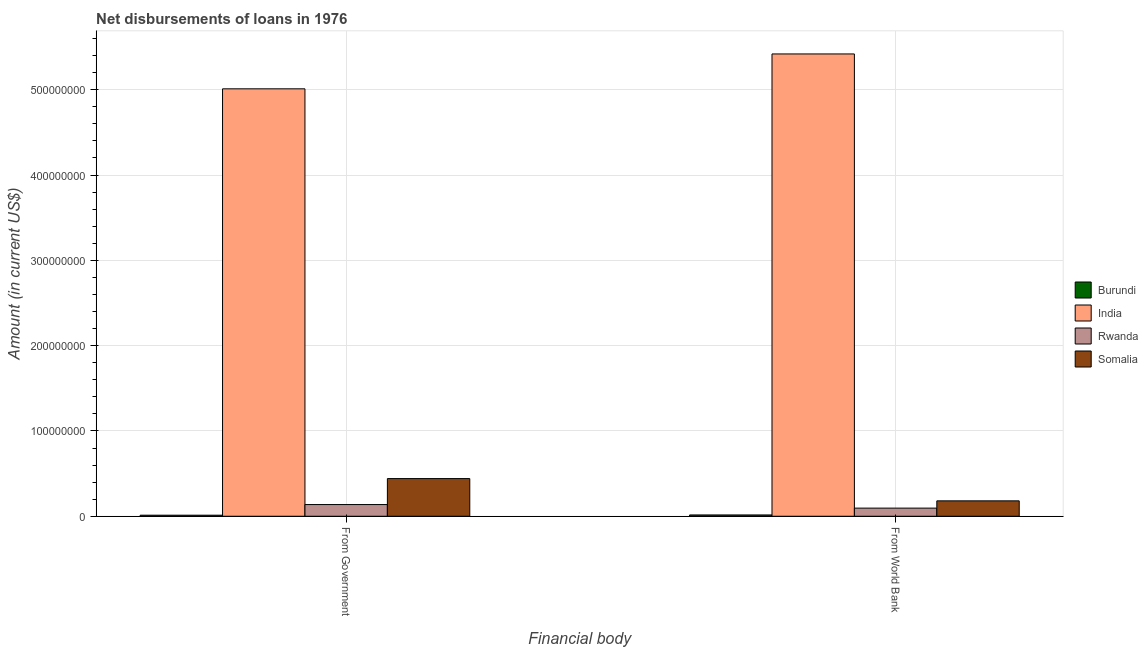Are the number of bars per tick equal to the number of legend labels?
Your answer should be compact. Yes. Are the number of bars on each tick of the X-axis equal?
Provide a succinct answer. Yes. How many bars are there on the 2nd tick from the right?
Offer a very short reply. 4. What is the label of the 2nd group of bars from the left?
Your response must be concise. From World Bank. What is the net disbursements of loan from government in India?
Keep it short and to the point. 5.01e+08. Across all countries, what is the maximum net disbursements of loan from government?
Provide a succinct answer. 5.01e+08. Across all countries, what is the minimum net disbursements of loan from world bank?
Your answer should be very brief. 1.54e+06. In which country was the net disbursements of loan from government maximum?
Offer a terse response. India. In which country was the net disbursements of loan from world bank minimum?
Make the answer very short. Burundi. What is the total net disbursements of loan from government in the graph?
Your response must be concise. 5.60e+08. What is the difference between the net disbursements of loan from government in Rwanda and that in Burundi?
Provide a succinct answer. 1.25e+07. What is the difference between the net disbursements of loan from government in Rwanda and the net disbursements of loan from world bank in Burundi?
Offer a very short reply. 1.22e+07. What is the average net disbursements of loan from government per country?
Ensure brevity in your answer.  1.40e+08. What is the difference between the net disbursements of loan from world bank and net disbursements of loan from government in Burundi?
Give a very brief answer. 3.03e+05. What is the ratio of the net disbursements of loan from world bank in Burundi to that in India?
Ensure brevity in your answer.  0. What does the 1st bar from the left in From Government represents?
Your answer should be very brief. Burundi. What does the 3rd bar from the right in From Government represents?
Keep it short and to the point. India. How many bars are there?
Offer a very short reply. 8. How many countries are there in the graph?
Provide a succinct answer. 4. Does the graph contain grids?
Your response must be concise. Yes. Where does the legend appear in the graph?
Keep it short and to the point. Center right. How many legend labels are there?
Provide a succinct answer. 4. What is the title of the graph?
Your answer should be very brief. Net disbursements of loans in 1976. What is the label or title of the X-axis?
Offer a very short reply. Financial body. What is the Amount (in current US$) in Burundi in From Government?
Keep it short and to the point. 1.24e+06. What is the Amount (in current US$) in India in From Government?
Provide a short and direct response. 5.01e+08. What is the Amount (in current US$) in Rwanda in From Government?
Your response must be concise. 1.37e+07. What is the Amount (in current US$) in Somalia in From Government?
Your response must be concise. 4.42e+07. What is the Amount (in current US$) of Burundi in From World Bank?
Provide a short and direct response. 1.54e+06. What is the Amount (in current US$) in India in From World Bank?
Ensure brevity in your answer.  5.42e+08. What is the Amount (in current US$) in Rwanda in From World Bank?
Your answer should be compact. 9.53e+06. What is the Amount (in current US$) in Somalia in From World Bank?
Your answer should be very brief. 1.81e+07. Across all Financial body, what is the maximum Amount (in current US$) of Burundi?
Your response must be concise. 1.54e+06. Across all Financial body, what is the maximum Amount (in current US$) in India?
Give a very brief answer. 5.42e+08. Across all Financial body, what is the maximum Amount (in current US$) of Rwanda?
Give a very brief answer. 1.37e+07. Across all Financial body, what is the maximum Amount (in current US$) in Somalia?
Offer a very short reply. 4.42e+07. Across all Financial body, what is the minimum Amount (in current US$) of Burundi?
Your answer should be very brief. 1.24e+06. Across all Financial body, what is the minimum Amount (in current US$) of India?
Offer a terse response. 5.01e+08. Across all Financial body, what is the minimum Amount (in current US$) in Rwanda?
Give a very brief answer. 9.53e+06. Across all Financial body, what is the minimum Amount (in current US$) of Somalia?
Offer a very short reply. 1.81e+07. What is the total Amount (in current US$) of Burundi in the graph?
Your answer should be very brief. 2.78e+06. What is the total Amount (in current US$) of India in the graph?
Give a very brief answer. 1.04e+09. What is the total Amount (in current US$) of Rwanda in the graph?
Offer a very short reply. 2.32e+07. What is the total Amount (in current US$) in Somalia in the graph?
Your answer should be very brief. 6.22e+07. What is the difference between the Amount (in current US$) in Burundi in From Government and that in From World Bank?
Offer a very short reply. -3.03e+05. What is the difference between the Amount (in current US$) of India in From Government and that in From World Bank?
Your answer should be compact. -4.09e+07. What is the difference between the Amount (in current US$) in Rwanda in From Government and that in From World Bank?
Provide a succinct answer. 4.18e+06. What is the difference between the Amount (in current US$) of Somalia in From Government and that in From World Bank?
Ensure brevity in your answer.  2.61e+07. What is the difference between the Amount (in current US$) in Burundi in From Government and the Amount (in current US$) in India in From World Bank?
Provide a succinct answer. -5.41e+08. What is the difference between the Amount (in current US$) of Burundi in From Government and the Amount (in current US$) of Rwanda in From World Bank?
Give a very brief answer. -8.29e+06. What is the difference between the Amount (in current US$) in Burundi in From Government and the Amount (in current US$) in Somalia in From World Bank?
Keep it short and to the point. -1.68e+07. What is the difference between the Amount (in current US$) in India in From Government and the Amount (in current US$) in Rwanda in From World Bank?
Provide a short and direct response. 4.91e+08. What is the difference between the Amount (in current US$) of India in From Government and the Amount (in current US$) of Somalia in From World Bank?
Ensure brevity in your answer.  4.83e+08. What is the difference between the Amount (in current US$) in Rwanda in From Government and the Amount (in current US$) in Somalia in From World Bank?
Provide a succinct answer. -4.36e+06. What is the average Amount (in current US$) in Burundi per Financial body?
Provide a short and direct response. 1.39e+06. What is the average Amount (in current US$) in India per Financial body?
Provide a succinct answer. 5.21e+08. What is the average Amount (in current US$) of Rwanda per Financial body?
Give a very brief answer. 1.16e+07. What is the average Amount (in current US$) in Somalia per Financial body?
Your answer should be very brief. 3.11e+07. What is the difference between the Amount (in current US$) of Burundi and Amount (in current US$) of India in From Government?
Ensure brevity in your answer.  -5.00e+08. What is the difference between the Amount (in current US$) in Burundi and Amount (in current US$) in Rwanda in From Government?
Offer a very short reply. -1.25e+07. What is the difference between the Amount (in current US$) in Burundi and Amount (in current US$) in Somalia in From Government?
Keep it short and to the point. -4.29e+07. What is the difference between the Amount (in current US$) of India and Amount (in current US$) of Rwanda in From Government?
Give a very brief answer. 4.87e+08. What is the difference between the Amount (in current US$) of India and Amount (in current US$) of Somalia in From Government?
Offer a very short reply. 4.57e+08. What is the difference between the Amount (in current US$) in Rwanda and Amount (in current US$) in Somalia in From Government?
Provide a short and direct response. -3.04e+07. What is the difference between the Amount (in current US$) of Burundi and Amount (in current US$) of India in From World Bank?
Your response must be concise. -5.40e+08. What is the difference between the Amount (in current US$) of Burundi and Amount (in current US$) of Rwanda in From World Bank?
Give a very brief answer. -7.99e+06. What is the difference between the Amount (in current US$) of Burundi and Amount (in current US$) of Somalia in From World Bank?
Your answer should be very brief. -1.65e+07. What is the difference between the Amount (in current US$) in India and Amount (in current US$) in Rwanda in From World Bank?
Offer a very short reply. 5.32e+08. What is the difference between the Amount (in current US$) of India and Amount (in current US$) of Somalia in From World Bank?
Provide a succinct answer. 5.24e+08. What is the difference between the Amount (in current US$) in Rwanda and Amount (in current US$) in Somalia in From World Bank?
Provide a succinct answer. -8.53e+06. What is the ratio of the Amount (in current US$) of Burundi in From Government to that in From World Bank?
Make the answer very short. 0.8. What is the ratio of the Amount (in current US$) of India in From Government to that in From World Bank?
Your response must be concise. 0.92. What is the ratio of the Amount (in current US$) in Rwanda in From Government to that in From World Bank?
Offer a very short reply. 1.44. What is the ratio of the Amount (in current US$) in Somalia in From Government to that in From World Bank?
Make the answer very short. 2.44. What is the difference between the highest and the second highest Amount (in current US$) in Burundi?
Your answer should be very brief. 3.03e+05. What is the difference between the highest and the second highest Amount (in current US$) of India?
Give a very brief answer. 4.09e+07. What is the difference between the highest and the second highest Amount (in current US$) of Rwanda?
Make the answer very short. 4.18e+06. What is the difference between the highest and the second highest Amount (in current US$) of Somalia?
Your answer should be very brief. 2.61e+07. What is the difference between the highest and the lowest Amount (in current US$) of Burundi?
Keep it short and to the point. 3.03e+05. What is the difference between the highest and the lowest Amount (in current US$) in India?
Ensure brevity in your answer.  4.09e+07. What is the difference between the highest and the lowest Amount (in current US$) in Rwanda?
Offer a very short reply. 4.18e+06. What is the difference between the highest and the lowest Amount (in current US$) in Somalia?
Ensure brevity in your answer.  2.61e+07. 